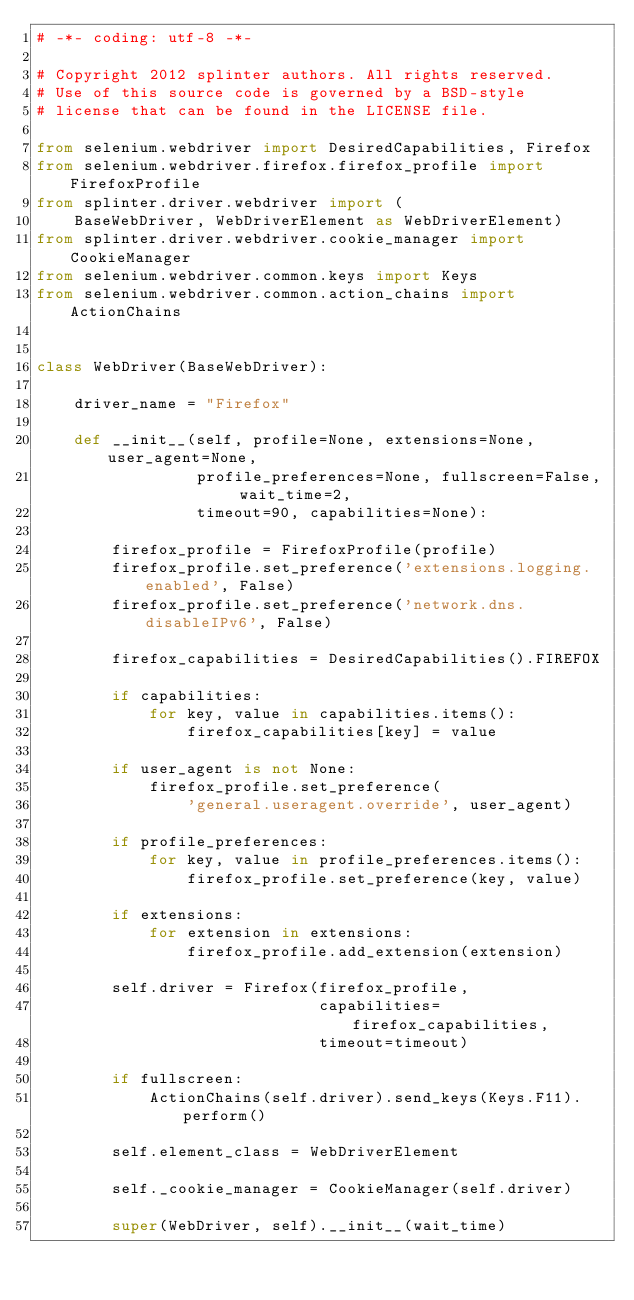<code> <loc_0><loc_0><loc_500><loc_500><_Python_># -*- coding: utf-8 -*-

# Copyright 2012 splinter authors. All rights reserved.
# Use of this source code is governed by a BSD-style
# license that can be found in the LICENSE file.

from selenium.webdriver import DesiredCapabilities, Firefox
from selenium.webdriver.firefox.firefox_profile import FirefoxProfile
from splinter.driver.webdriver import (
    BaseWebDriver, WebDriverElement as WebDriverElement)
from splinter.driver.webdriver.cookie_manager import CookieManager
from selenium.webdriver.common.keys import Keys
from selenium.webdriver.common.action_chains import ActionChains


class WebDriver(BaseWebDriver):

    driver_name = "Firefox"

    def __init__(self, profile=None, extensions=None, user_agent=None,
                 profile_preferences=None, fullscreen=False, wait_time=2,
                 timeout=90, capabilities=None):

        firefox_profile = FirefoxProfile(profile)
        firefox_profile.set_preference('extensions.logging.enabled', False)
        firefox_profile.set_preference('network.dns.disableIPv6', False)

        firefox_capabilities = DesiredCapabilities().FIREFOX

        if capabilities:
            for key, value in capabilities.items():
                firefox_capabilities[key] = value

        if user_agent is not None:
            firefox_profile.set_preference(
                'general.useragent.override', user_agent)

        if profile_preferences:
            for key, value in profile_preferences.items():
                firefox_profile.set_preference(key, value)

        if extensions:
            for extension in extensions:
                firefox_profile.add_extension(extension)

        self.driver = Firefox(firefox_profile,
                              capabilities=firefox_capabilities,
                              timeout=timeout)

        if fullscreen:
            ActionChains(self.driver).send_keys(Keys.F11).perform()

        self.element_class = WebDriverElement

        self._cookie_manager = CookieManager(self.driver)

        super(WebDriver, self).__init__(wait_time)
</code> 